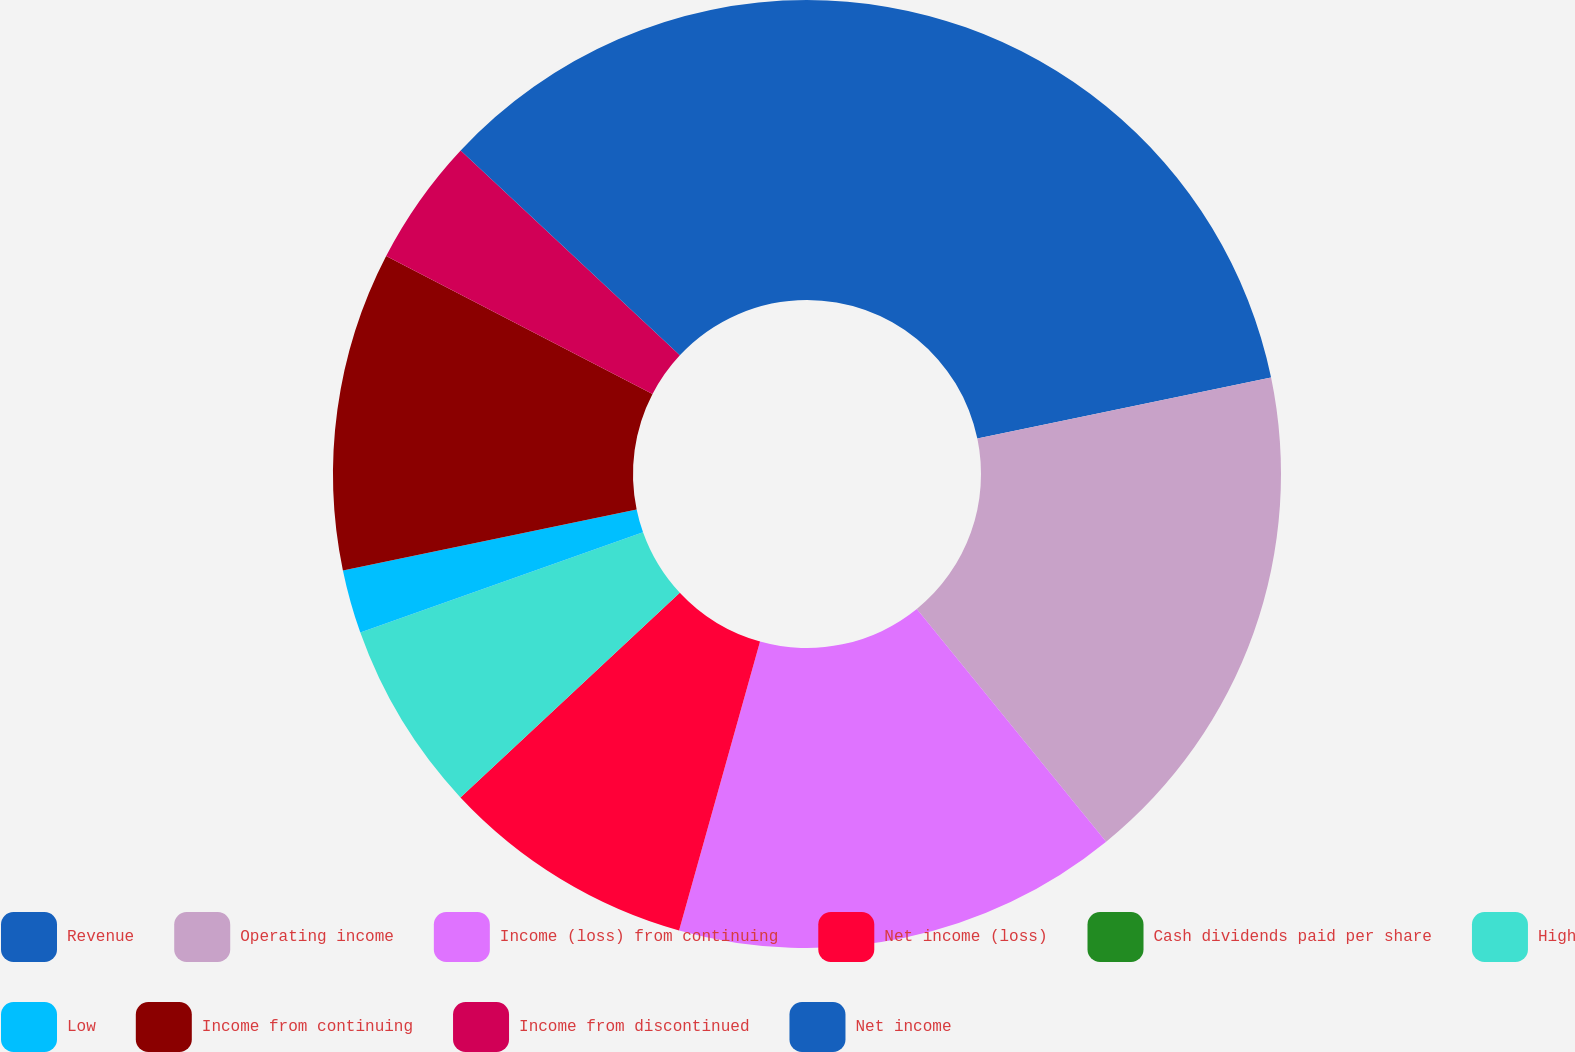<chart> <loc_0><loc_0><loc_500><loc_500><pie_chart><fcel>Revenue<fcel>Operating income<fcel>Income (loss) from continuing<fcel>Net income (loss)<fcel>Cash dividends paid per share<fcel>High<fcel>Low<fcel>Income from continuing<fcel>Income from discontinued<fcel>Net income<nl><fcel>21.74%<fcel>17.39%<fcel>15.22%<fcel>8.7%<fcel>0.0%<fcel>6.52%<fcel>2.17%<fcel>10.87%<fcel>4.35%<fcel>13.04%<nl></chart> 